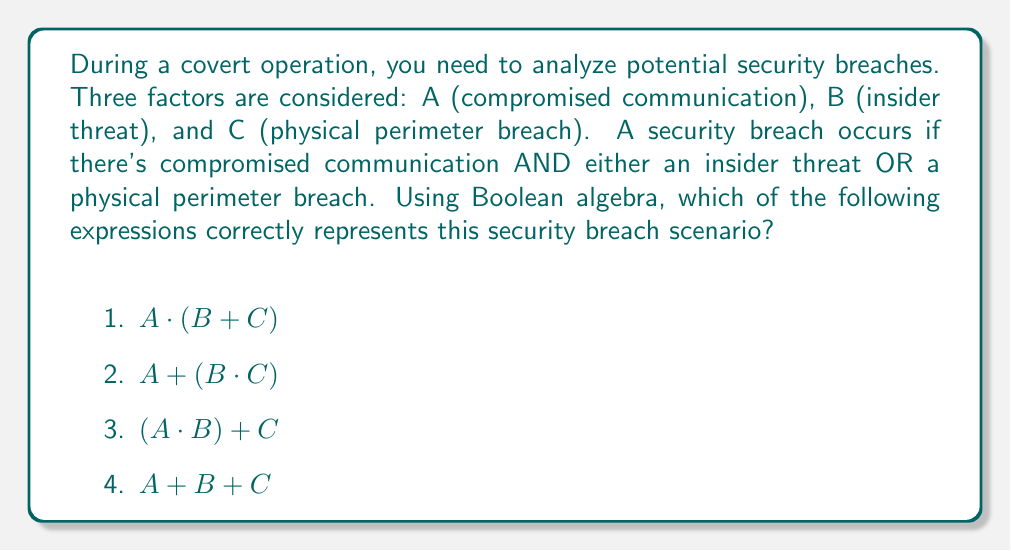What is the answer to this math problem? Let's break this down step-by-step:

1) We need to translate the given scenario into Boolean algebra.

2) The scenario states: A security breach occurs if there's compromised communication AND either an insider threat OR a physical perimeter breach.

3) Let's define our Boolean variables:
   A: Compromised communication
   B: Insider threat
   C: Physical perimeter breach

4) The word "AND" in Boolean algebra is represented by multiplication (·).
   The word "OR" in Boolean algebra is represented by addition (+).

5) We need A AND (B OR C). In Boolean algebra, this translates to:

   $A \cdot (B + C)$

6) This matches option 1 in the given choices.

7) Let's quickly check why the other options are incorrect:
   - Option 2: $A + (B \cdot C)$ would mean A OR (B AND C), which is not what we want.
   - Option 3: $(A \cdot B) + C$ would mean (A AND B) OR C, which is also incorrect.
   - Option 4: $A + B + C$ would mean A OR B OR C, which doesn't capture the AND condition.

Therefore, the correct expression is $A \cdot (B + C)$.
Answer: $A \cdot (B + C)$ 